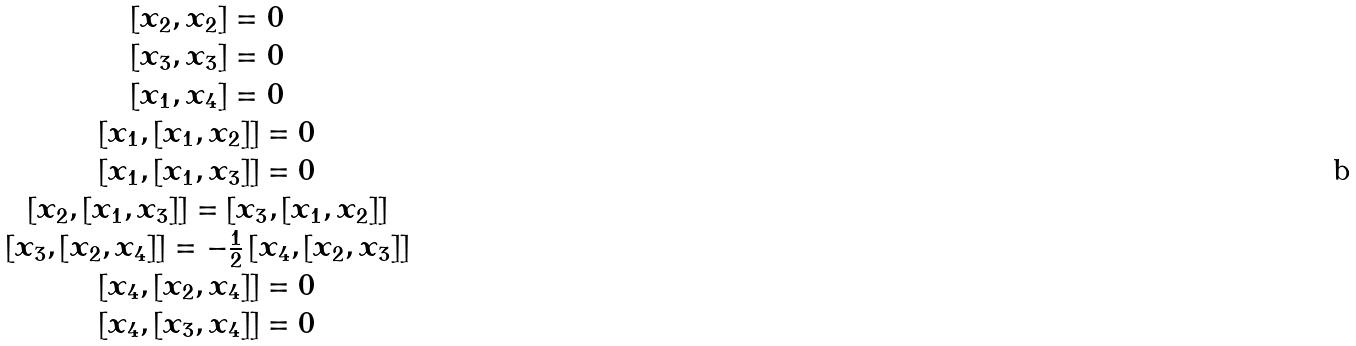Convert formula to latex. <formula><loc_0><loc_0><loc_500><loc_500>\begin{matrix} { { [ x _ { 2 } , x _ { 2 } ] } = 0 } \\ { { [ x _ { 3 } , x _ { 3 } ] } = 0 } \\ { { [ x _ { 1 } , x _ { 4 } ] } = 0 } \\ { { [ x _ { 1 } , [ x _ { 1 } , x _ { 2 } ] ] } = 0 } \\ { { [ x _ { 1 } , [ x _ { 1 } , x _ { 3 } ] ] } = 0 } \\ { { [ x _ { 2 } , [ x _ { 1 } , x _ { 3 } ] ] } = { [ x _ { 3 } , [ x _ { 1 } , x _ { 2 } ] ] } } \\ { { [ x _ { 3 } , [ x _ { 2 } , x _ { 4 } ] ] } = { - \frac { 1 } { 2 } \, [ x _ { 4 } , [ x _ { 2 } , x _ { 3 } ] ] } } \\ { { [ x _ { 4 } , [ x _ { 2 } , x _ { 4 } ] ] } = 0 } \\ { { [ x _ { 4 } , [ x _ { 3 } , x _ { 4 } ] ] } = 0 } \end{matrix}</formula> 